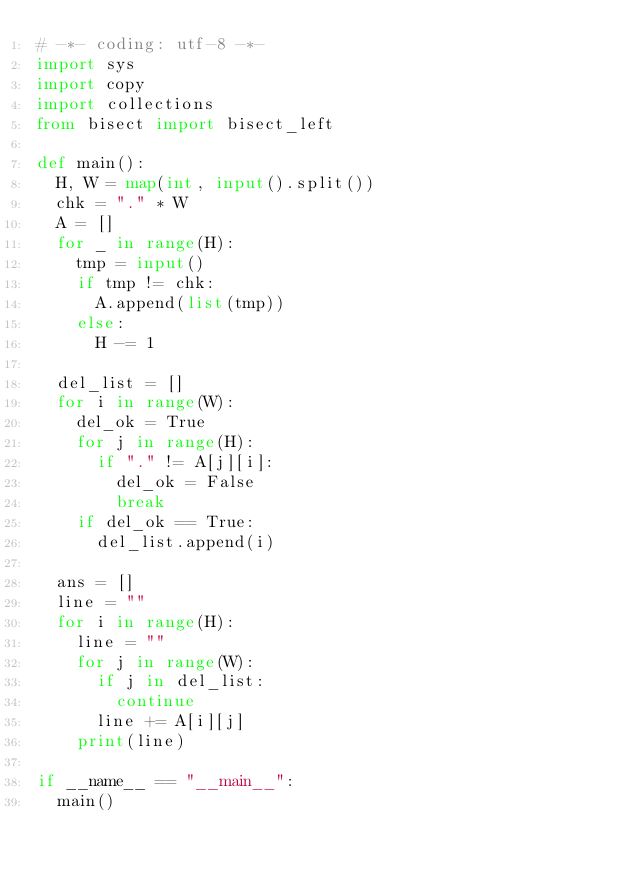Convert code to text. <code><loc_0><loc_0><loc_500><loc_500><_Python_># -*- coding: utf-8 -*-
import sys
import copy
import collections
from bisect import bisect_left
	
def main():
	H, W = map(int, input().split())
	chk = "." * W
	A = []
	for _ in range(H):
		tmp = input()
		if tmp != chk:
			A.append(list(tmp))
		else:
			H -= 1
			
	del_list = []
	for i in range(W):
		del_ok = True
		for j in range(H):
			if "." != A[j][i]:
				del_ok = False
				break
		if del_ok == True:
			del_list.append(i)
			
	ans = []
	line = ""
	for i in range(H):
		line = ""
		for j in range(W):
			if j in del_list:
				continue
			line += A[i][j]
		print(line)
	
if __name__ == "__main__":
	main()
</code> 